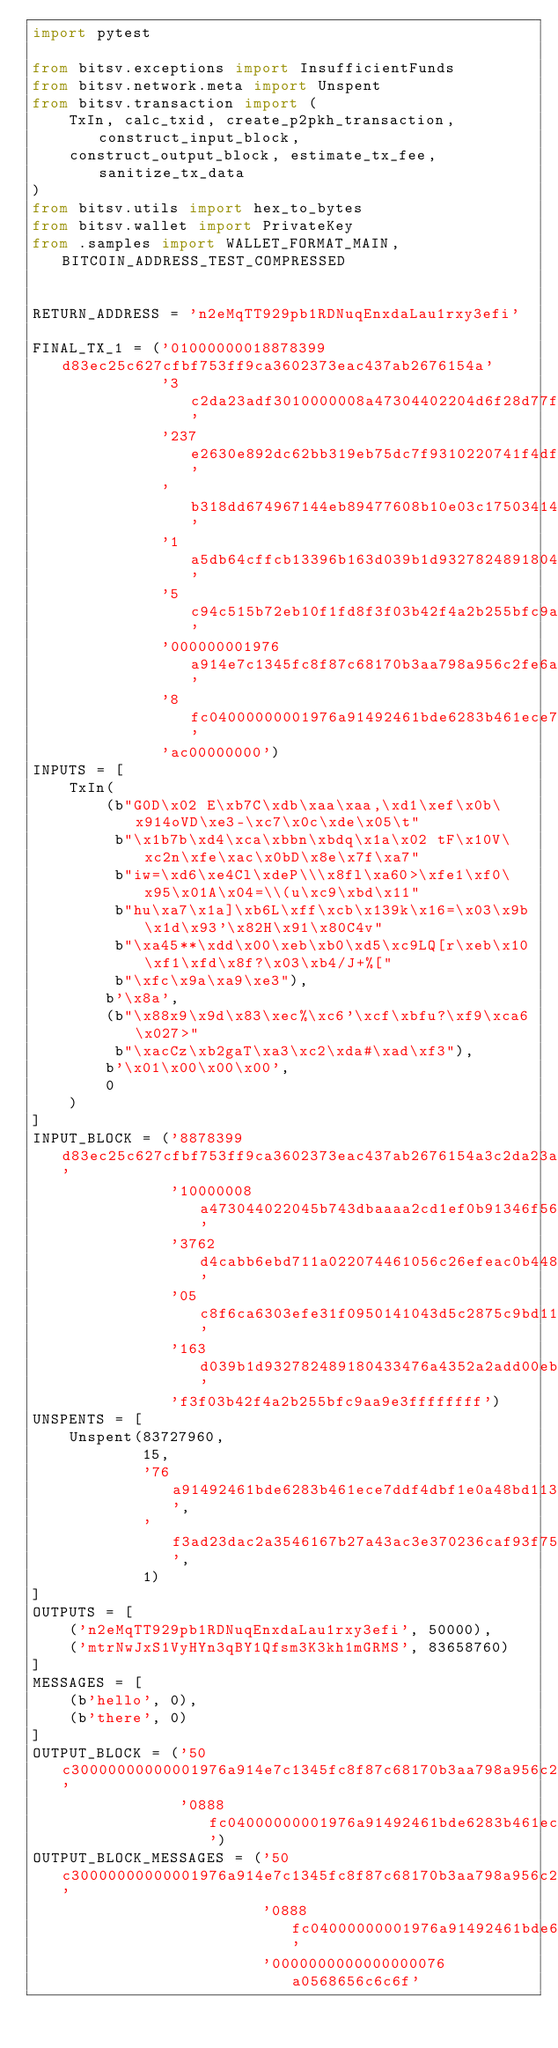Convert code to text. <code><loc_0><loc_0><loc_500><loc_500><_Python_>import pytest

from bitsv.exceptions import InsufficientFunds
from bitsv.network.meta import Unspent
from bitsv.transaction import (
    TxIn, calc_txid, create_p2pkh_transaction, construct_input_block,
    construct_output_block, estimate_tx_fee, sanitize_tx_data
)
from bitsv.utils import hex_to_bytes
from bitsv.wallet import PrivateKey
from .samples import WALLET_FORMAT_MAIN, BITCOIN_ADDRESS_TEST_COMPRESSED


RETURN_ADDRESS = 'n2eMqTT929pb1RDNuqEnxdaLau1rxy3efi'

FINAL_TX_1 = ('01000000018878399d83ec25c627cfbf753ff9ca3602373eac437ab2676154a'
              '3c2da23adf3010000008a47304402204d6f28d77fa31cfc6c13bb1bda2628f2'
              '237e2630e892dc62bb319eb75dc7f9310220741f4df7d9460daa844389eb23f'
              'b318dd674967144eb89477608b10e03c175034141043d5c2875c9bd116875a7'
              '1a5db64cffcb13396b163d039b1d932782489180433476a4352a2add00ebb0d'
              '5c94c515b72eb10f1fd8f3f03b42f4a2b255bfc9aa9e3ffffffff0250c30000'
              '000000001976a914e7c1345fc8f87c68170b3aa798a956c2fe6a9eff88ac088'
              '8fc04000000001976a91492461bde6283b461ece7ddf4dbf1e0a48bd113d888'
              'ac00000000')
INPUTS = [
    TxIn(
        (b"G0D\x02 E\xb7C\xdb\xaa\xaa,\xd1\xef\x0b\x914oVD\xe3-\xc7\x0c\xde\x05\t"
         b"\x1b7b\xd4\xca\xbbn\xbdq\x1a\x02 tF\x10V\xc2n\xfe\xac\x0bD\x8e\x7f\xa7"
         b"iw=\xd6\xe4Cl\xdeP\\\x8fl\xa60>\xfe1\xf0\x95\x01A\x04=\\(u\xc9\xbd\x11"
         b"hu\xa7\x1a]\xb6L\xff\xcb\x139k\x16=\x03\x9b\x1d\x93'\x82H\x91\x80C4v"
         b"\xa45**\xdd\x00\xeb\xb0\xd5\xc9LQ[r\xeb\x10\xf1\xfd\x8f?\x03\xb4/J+%["
         b"\xfc\x9a\xa9\xe3"),
        b'\x8a',
        (b"\x88x9\x9d\x83\xec%\xc6'\xcf\xbfu?\xf9\xca6\x027>"
         b"\xacCz\xb2gaT\xa3\xc2\xda#\xad\xf3"),
        b'\x01\x00\x00\x00',
        0
    )
]
INPUT_BLOCK = ('8878399d83ec25c627cfbf753ff9ca3602373eac437ab2676154a3c2da23adf30'
               '10000008a473044022045b743dbaaaa2cd1ef0b91346f5644e32dc70cde05091b'
               '3762d4cabb6ebd711a022074461056c26efeac0b448e7fa769773dd6e4436cde5'
               '05c8f6ca6303efe31f0950141043d5c2875c9bd116875a71a5db64cffcb13396b'
               '163d039b1d932782489180433476a4352a2add00ebb0d5c94c515b72eb10f1fd8'
               'f3f03b42f4a2b255bfc9aa9e3ffffffff')
UNSPENTS = [
    Unspent(83727960,
            15,
            '76a91492461bde6283b461ece7ddf4dbf1e0a48bd113d888ac',
            'f3ad23dac2a3546167b27a43ac3e370236caf93f75bfcf27c625ec839d397888',
            1)
]
OUTPUTS = [
    ('n2eMqTT929pb1RDNuqEnxdaLau1rxy3efi', 50000),
    ('mtrNwJxS1VyHYn3qBY1Qfsm3K3kh1mGRMS', 83658760)
]
MESSAGES = [
    (b'hello', 0),
    (b'there', 0)
]
OUTPUT_BLOCK = ('50c30000000000001976a914e7c1345fc8f87c68170b3aa798a956c2fe6a9eff88ac'
                '0888fc04000000001976a91492461bde6283b461ece7ddf4dbf1e0a48bd113d888ac')
OUTPUT_BLOCK_MESSAGES = ('50c30000000000001976a914e7c1345fc8f87c68170b3aa798a956c2fe6a9eff88ac'
                         '0888fc04000000001976a91492461bde6283b461ece7ddf4dbf1e0a48bd113d888ac'
                         '0000000000000000076a0568656c6c6f'</code> 